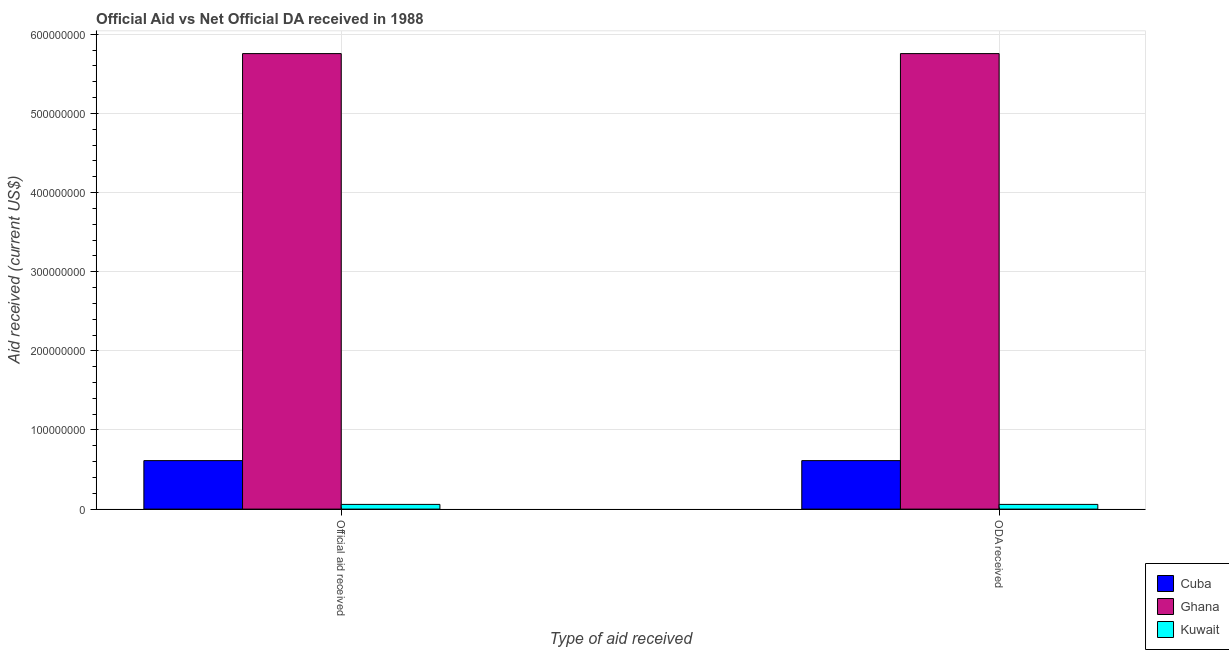How many different coloured bars are there?
Offer a terse response. 3. Are the number of bars per tick equal to the number of legend labels?
Your response must be concise. Yes. Are the number of bars on each tick of the X-axis equal?
Provide a short and direct response. Yes. What is the label of the 2nd group of bars from the left?
Keep it short and to the point. ODA received. What is the oda received in Ghana?
Your response must be concise. 5.76e+08. Across all countries, what is the maximum oda received?
Ensure brevity in your answer.  5.76e+08. Across all countries, what is the minimum oda received?
Make the answer very short. 5.94e+06. In which country was the official aid received minimum?
Keep it short and to the point. Kuwait. What is the total official aid received in the graph?
Provide a short and direct response. 6.43e+08. What is the difference between the oda received in Cuba and that in Kuwait?
Your response must be concise. 5.53e+07. What is the difference between the official aid received in Ghana and the oda received in Kuwait?
Make the answer very short. 5.70e+08. What is the average official aid received per country?
Keep it short and to the point. 2.14e+08. What is the difference between the official aid received and oda received in Cuba?
Offer a terse response. 0. What is the ratio of the oda received in Kuwait to that in Cuba?
Offer a very short reply. 0.1. Is the oda received in Cuba less than that in Ghana?
Provide a short and direct response. Yes. What does the 3rd bar from the left in Official aid received represents?
Your response must be concise. Kuwait. What does the 3rd bar from the right in Official aid received represents?
Your response must be concise. Cuba. Does the graph contain any zero values?
Ensure brevity in your answer.  No. How many legend labels are there?
Make the answer very short. 3. What is the title of the graph?
Ensure brevity in your answer.  Official Aid vs Net Official DA received in 1988 . Does "Chile" appear as one of the legend labels in the graph?
Your answer should be compact. No. What is the label or title of the X-axis?
Provide a short and direct response. Type of aid received. What is the label or title of the Y-axis?
Give a very brief answer. Aid received (current US$). What is the Aid received (current US$) in Cuba in Official aid received?
Give a very brief answer. 6.13e+07. What is the Aid received (current US$) of Ghana in Official aid received?
Give a very brief answer. 5.76e+08. What is the Aid received (current US$) of Kuwait in Official aid received?
Offer a very short reply. 5.94e+06. What is the Aid received (current US$) of Cuba in ODA received?
Ensure brevity in your answer.  6.13e+07. What is the Aid received (current US$) in Ghana in ODA received?
Your response must be concise. 5.76e+08. What is the Aid received (current US$) in Kuwait in ODA received?
Offer a very short reply. 5.94e+06. Across all Type of aid received, what is the maximum Aid received (current US$) of Cuba?
Make the answer very short. 6.13e+07. Across all Type of aid received, what is the maximum Aid received (current US$) in Ghana?
Provide a short and direct response. 5.76e+08. Across all Type of aid received, what is the maximum Aid received (current US$) of Kuwait?
Your response must be concise. 5.94e+06. Across all Type of aid received, what is the minimum Aid received (current US$) of Cuba?
Your answer should be very brief. 6.13e+07. Across all Type of aid received, what is the minimum Aid received (current US$) of Ghana?
Provide a short and direct response. 5.76e+08. Across all Type of aid received, what is the minimum Aid received (current US$) of Kuwait?
Your answer should be compact. 5.94e+06. What is the total Aid received (current US$) in Cuba in the graph?
Your answer should be very brief. 1.23e+08. What is the total Aid received (current US$) in Ghana in the graph?
Give a very brief answer. 1.15e+09. What is the total Aid received (current US$) of Kuwait in the graph?
Give a very brief answer. 1.19e+07. What is the difference between the Aid received (current US$) of Cuba in Official aid received and that in ODA received?
Provide a short and direct response. 0. What is the difference between the Aid received (current US$) of Ghana in Official aid received and that in ODA received?
Your response must be concise. 0. What is the difference between the Aid received (current US$) of Kuwait in Official aid received and that in ODA received?
Keep it short and to the point. 0. What is the difference between the Aid received (current US$) of Cuba in Official aid received and the Aid received (current US$) of Ghana in ODA received?
Keep it short and to the point. -5.14e+08. What is the difference between the Aid received (current US$) of Cuba in Official aid received and the Aid received (current US$) of Kuwait in ODA received?
Offer a very short reply. 5.53e+07. What is the difference between the Aid received (current US$) of Ghana in Official aid received and the Aid received (current US$) of Kuwait in ODA received?
Ensure brevity in your answer.  5.70e+08. What is the average Aid received (current US$) in Cuba per Type of aid received?
Ensure brevity in your answer.  6.13e+07. What is the average Aid received (current US$) of Ghana per Type of aid received?
Offer a terse response. 5.76e+08. What is the average Aid received (current US$) of Kuwait per Type of aid received?
Provide a short and direct response. 5.94e+06. What is the difference between the Aid received (current US$) in Cuba and Aid received (current US$) in Ghana in Official aid received?
Your answer should be very brief. -5.14e+08. What is the difference between the Aid received (current US$) in Cuba and Aid received (current US$) in Kuwait in Official aid received?
Make the answer very short. 5.53e+07. What is the difference between the Aid received (current US$) of Ghana and Aid received (current US$) of Kuwait in Official aid received?
Offer a terse response. 5.70e+08. What is the difference between the Aid received (current US$) of Cuba and Aid received (current US$) of Ghana in ODA received?
Make the answer very short. -5.14e+08. What is the difference between the Aid received (current US$) in Cuba and Aid received (current US$) in Kuwait in ODA received?
Offer a terse response. 5.53e+07. What is the difference between the Aid received (current US$) of Ghana and Aid received (current US$) of Kuwait in ODA received?
Your response must be concise. 5.70e+08. What is the ratio of the Aid received (current US$) in Ghana in Official aid received to that in ODA received?
Your answer should be very brief. 1. What is the ratio of the Aid received (current US$) of Kuwait in Official aid received to that in ODA received?
Give a very brief answer. 1. What is the difference between the highest and the second highest Aid received (current US$) in Ghana?
Your response must be concise. 0. What is the difference between the highest and the lowest Aid received (current US$) in Cuba?
Keep it short and to the point. 0. What is the difference between the highest and the lowest Aid received (current US$) of Kuwait?
Your answer should be very brief. 0. 